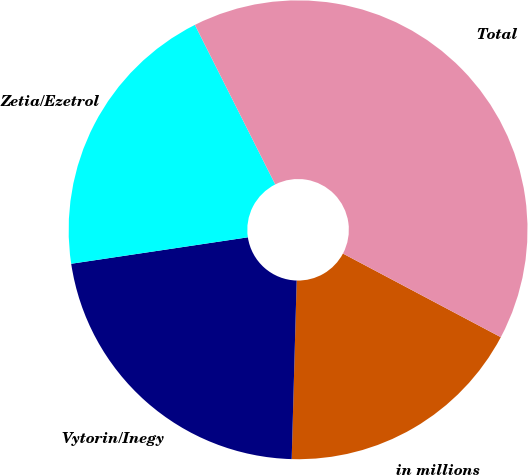Convert chart to OTSL. <chart><loc_0><loc_0><loc_500><loc_500><pie_chart><fcel>in millions<fcel>Vytorin/Inegy<fcel>Zetia/Ezetrol<fcel>Total<nl><fcel>17.69%<fcel>22.19%<fcel>19.94%<fcel>40.18%<nl></chart> 